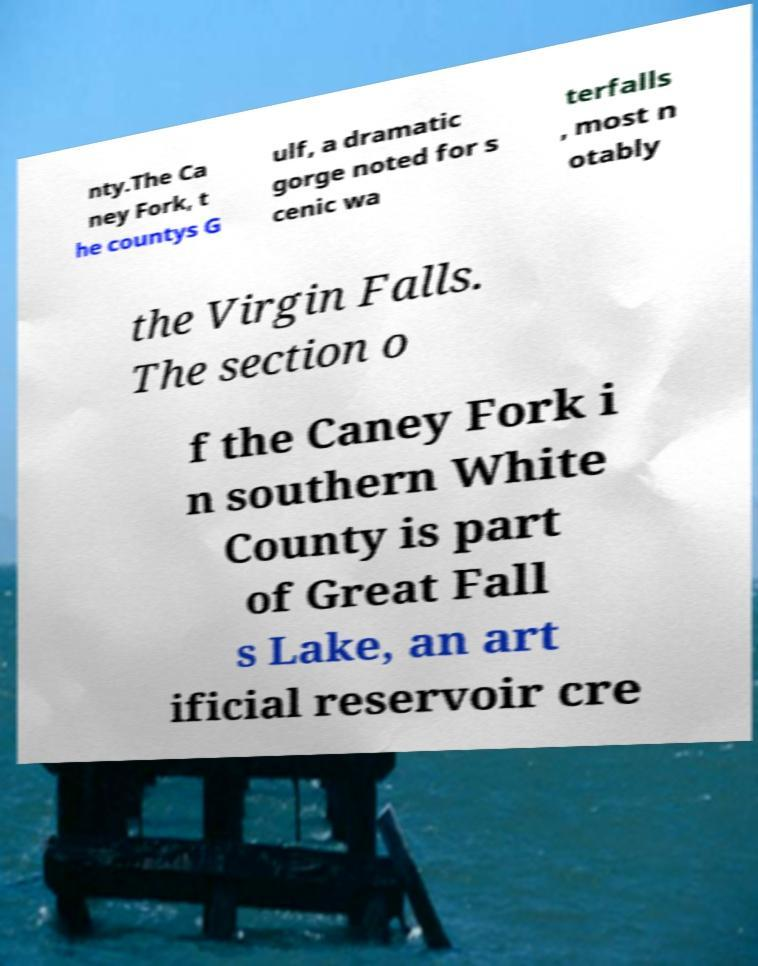Please identify and transcribe the text found in this image. nty.The Ca ney Fork, t he countys G ulf, a dramatic gorge noted for s cenic wa terfalls , most n otably the Virgin Falls. The section o f the Caney Fork i n southern White County is part of Great Fall s Lake, an art ificial reservoir cre 